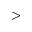Convert formula to latex. <formula><loc_0><loc_0><loc_500><loc_500>></formula> 